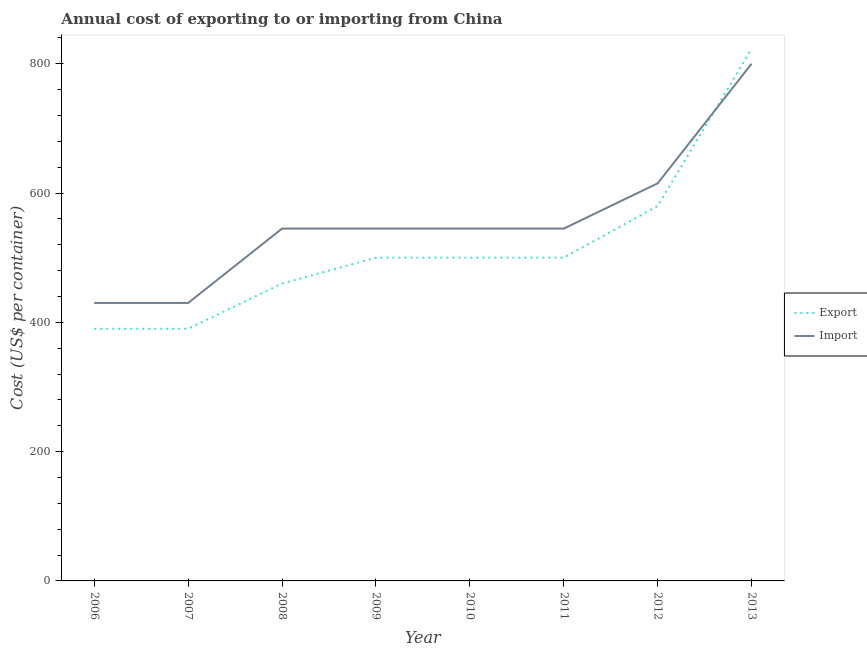Does the line corresponding to export cost intersect with the line corresponding to import cost?
Ensure brevity in your answer.  Yes. Is the number of lines equal to the number of legend labels?
Keep it short and to the point. Yes. What is the import cost in 2010?
Your response must be concise. 545. Across all years, what is the maximum export cost?
Your response must be concise. 823. Across all years, what is the minimum import cost?
Keep it short and to the point. 430. In which year was the import cost maximum?
Your answer should be very brief. 2013. What is the total import cost in the graph?
Offer a very short reply. 4455. What is the difference between the import cost in 2007 and that in 2013?
Your answer should be very brief. -370. What is the difference between the import cost in 2013 and the export cost in 2011?
Offer a very short reply. 300. What is the average import cost per year?
Offer a very short reply. 556.88. In the year 2006, what is the difference between the export cost and import cost?
Offer a terse response. -40. What is the ratio of the import cost in 2007 to that in 2009?
Your answer should be compact. 0.79. Is the difference between the import cost in 2006 and 2008 greater than the difference between the export cost in 2006 and 2008?
Your answer should be very brief. No. What is the difference between the highest and the second highest export cost?
Your answer should be compact. 243. What is the difference between the highest and the lowest export cost?
Provide a succinct answer. 433. Is the sum of the export cost in 2006 and 2010 greater than the maximum import cost across all years?
Your response must be concise. Yes. Is the export cost strictly greater than the import cost over the years?
Offer a terse response. No. How many lines are there?
Give a very brief answer. 2. How many years are there in the graph?
Keep it short and to the point. 8. Does the graph contain any zero values?
Provide a short and direct response. No. Does the graph contain grids?
Ensure brevity in your answer.  No. Where does the legend appear in the graph?
Offer a terse response. Center right. What is the title of the graph?
Keep it short and to the point. Annual cost of exporting to or importing from China. Does "All education staff compensation" appear as one of the legend labels in the graph?
Your response must be concise. No. What is the label or title of the Y-axis?
Make the answer very short. Cost (US$ per container). What is the Cost (US$ per container) in Export in 2006?
Provide a succinct answer. 390. What is the Cost (US$ per container) of Import in 2006?
Keep it short and to the point. 430. What is the Cost (US$ per container) of Export in 2007?
Your answer should be very brief. 390. What is the Cost (US$ per container) in Import in 2007?
Offer a terse response. 430. What is the Cost (US$ per container) in Export in 2008?
Your answer should be compact. 460. What is the Cost (US$ per container) in Import in 2008?
Provide a succinct answer. 545. What is the Cost (US$ per container) of Import in 2009?
Provide a short and direct response. 545. What is the Cost (US$ per container) of Export in 2010?
Give a very brief answer. 500. What is the Cost (US$ per container) in Import in 2010?
Provide a succinct answer. 545. What is the Cost (US$ per container) in Export in 2011?
Keep it short and to the point. 500. What is the Cost (US$ per container) of Import in 2011?
Your answer should be very brief. 545. What is the Cost (US$ per container) in Export in 2012?
Ensure brevity in your answer.  580. What is the Cost (US$ per container) of Import in 2012?
Provide a short and direct response. 615. What is the Cost (US$ per container) in Export in 2013?
Provide a short and direct response. 823. What is the Cost (US$ per container) of Import in 2013?
Your answer should be very brief. 800. Across all years, what is the maximum Cost (US$ per container) of Export?
Make the answer very short. 823. Across all years, what is the maximum Cost (US$ per container) in Import?
Give a very brief answer. 800. Across all years, what is the minimum Cost (US$ per container) in Export?
Ensure brevity in your answer.  390. Across all years, what is the minimum Cost (US$ per container) of Import?
Your response must be concise. 430. What is the total Cost (US$ per container) in Export in the graph?
Your answer should be very brief. 4143. What is the total Cost (US$ per container) of Import in the graph?
Offer a very short reply. 4455. What is the difference between the Cost (US$ per container) of Export in 2006 and that in 2007?
Your response must be concise. 0. What is the difference between the Cost (US$ per container) of Export in 2006 and that in 2008?
Your answer should be compact. -70. What is the difference between the Cost (US$ per container) of Import in 2006 and that in 2008?
Give a very brief answer. -115. What is the difference between the Cost (US$ per container) of Export in 2006 and that in 2009?
Your response must be concise. -110. What is the difference between the Cost (US$ per container) in Import in 2006 and that in 2009?
Your answer should be very brief. -115. What is the difference between the Cost (US$ per container) of Export in 2006 and that in 2010?
Provide a short and direct response. -110. What is the difference between the Cost (US$ per container) of Import in 2006 and that in 2010?
Your answer should be very brief. -115. What is the difference between the Cost (US$ per container) of Export in 2006 and that in 2011?
Provide a succinct answer. -110. What is the difference between the Cost (US$ per container) of Import in 2006 and that in 2011?
Offer a very short reply. -115. What is the difference between the Cost (US$ per container) of Export in 2006 and that in 2012?
Offer a very short reply. -190. What is the difference between the Cost (US$ per container) in Import in 2006 and that in 2012?
Your response must be concise. -185. What is the difference between the Cost (US$ per container) of Export in 2006 and that in 2013?
Ensure brevity in your answer.  -433. What is the difference between the Cost (US$ per container) in Import in 2006 and that in 2013?
Provide a succinct answer. -370. What is the difference between the Cost (US$ per container) of Export in 2007 and that in 2008?
Offer a very short reply. -70. What is the difference between the Cost (US$ per container) of Import in 2007 and that in 2008?
Make the answer very short. -115. What is the difference between the Cost (US$ per container) in Export in 2007 and that in 2009?
Your response must be concise. -110. What is the difference between the Cost (US$ per container) of Import in 2007 and that in 2009?
Keep it short and to the point. -115. What is the difference between the Cost (US$ per container) in Export in 2007 and that in 2010?
Your answer should be compact. -110. What is the difference between the Cost (US$ per container) of Import in 2007 and that in 2010?
Keep it short and to the point. -115. What is the difference between the Cost (US$ per container) in Export in 2007 and that in 2011?
Your response must be concise. -110. What is the difference between the Cost (US$ per container) of Import in 2007 and that in 2011?
Your answer should be very brief. -115. What is the difference between the Cost (US$ per container) in Export in 2007 and that in 2012?
Give a very brief answer. -190. What is the difference between the Cost (US$ per container) in Import in 2007 and that in 2012?
Offer a terse response. -185. What is the difference between the Cost (US$ per container) in Export in 2007 and that in 2013?
Ensure brevity in your answer.  -433. What is the difference between the Cost (US$ per container) of Import in 2007 and that in 2013?
Provide a succinct answer. -370. What is the difference between the Cost (US$ per container) of Export in 2008 and that in 2010?
Offer a very short reply. -40. What is the difference between the Cost (US$ per container) in Import in 2008 and that in 2010?
Provide a succinct answer. 0. What is the difference between the Cost (US$ per container) in Import in 2008 and that in 2011?
Provide a succinct answer. 0. What is the difference between the Cost (US$ per container) of Export in 2008 and that in 2012?
Give a very brief answer. -120. What is the difference between the Cost (US$ per container) of Import in 2008 and that in 2012?
Provide a short and direct response. -70. What is the difference between the Cost (US$ per container) of Export in 2008 and that in 2013?
Your response must be concise. -363. What is the difference between the Cost (US$ per container) in Import in 2008 and that in 2013?
Make the answer very short. -255. What is the difference between the Cost (US$ per container) of Export in 2009 and that in 2010?
Ensure brevity in your answer.  0. What is the difference between the Cost (US$ per container) of Import in 2009 and that in 2010?
Offer a very short reply. 0. What is the difference between the Cost (US$ per container) in Import in 2009 and that in 2011?
Your answer should be very brief. 0. What is the difference between the Cost (US$ per container) of Export in 2009 and that in 2012?
Offer a very short reply. -80. What is the difference between the Cost (US$ per container) in Import in 2009 and that in 2012?
Make the answer very short. -70. What is the difference between the Cost (US$ per container) in Export in 2009 and that in 2013?
Provide a short and direct response. -323. What is the difference between the Cost (US$ per container) in Import in 2009 and that in 2013?
Your response must be concise. -255. What is the difference between the Cost (US$ per container) of Export in 2010 and that in 2012?
Your answer should be very brief. -80. What is the difference between the Cost (US$ per container) in Import in 2010 and that in 2012?
Your response must be concise. -70. What is the difference between the Cost (US$ per container) of Export in 2010 and that in 2013?
Your response must be concise. -323. What is the difference between the Cost (US$ per container) of Import in 2010 and that in 2013?
Offer a very short reply. -255. What is the difference between the Cost (US$ per container) in Export in 2011 and that in 2012?
Your answer should be compact. -80. What is the difference between the Cost (US$ per container) of Import in 2011 and that in 2012?
Give a very brief answer. -70. What is the difference between the Cost (US$ per container) in Export in 2011 and that in 2013?
Offer a very short reply. -323. What is the difference between the Cost (US$ per container) in Import in 2011 and that in 2013?
Offer a very short reply. -255. What is the difference between the Cost (US$ per container) of Export in 2012 and that in 2013?
Keep it short and to the point. -243. What is the difference between the Cost (US$ per container) of Import in 2012 and that in 2013?
Make the answer very short. -185. What is the difference between the Cost (US$ per container) of Export in 2006 and the Cost (US$ per container) of Import in 2008?
Offer a very short reply. -155. What is the difference between the Cost (US$ per container) in Export in 2006 and the Cost (US$ per container) in Import in 2009?
Make the answer very short. -155. What is the difference between the Cost (US$ per container) in Export in 2006 and the Cost (US$ per container) in Import in 2010?
Provide a short and direct response. -155. What is the difference between the Cost (US$ per container) of Export in 2006 and the Cost (US$ per container) of Import in 2011?
Your answer should be compact. -155. What is the difference between the Cost (US$ per container) of Export in 2006 and the Cost (US$ per container) of Import in 2012?
Keep it short and to the point. -225. What is the difference between the Cost (US$ per container) in Export in 2006 and the Cost (US$ per container) in Import in 2013?
Provide a succinct answer. -410. What is the difference between the Cost (US$ per container) of Export in 2007 and the Cost (US$ per container) of Import in 2008?
Keep it short and to the point. -155. What is the difference between the Cost (US$ per container) of Export in 2007 and the Cost (US$ per container) of Import in 2009?
Your response must be concise. -155. What is the difference between the Cost (US$ per container) of Export in 2007 and the Cost (US$ per container) of Import in 2010?
Provide a short and direct response. -155. What is the difference between the Cost (US$ per container) in Export in 2007 and the Cost (US$ per container) in Import in 2011?
Provide a succinct answer. -155. What is the difference between the Cost (US$ per container) in Export in 2007 and the Cost (US$ per container) in Import in 2012?
Your response must be concise. -225. What is the difference between the Cost (US$ per container) of Export in 2007 and the Cost (US$ per container) of Import in 2013?
Ensure brevity in your answer.  -410. What is the difference between the Cost (US$ per container) in Export in 2008 and the Cost (US$ per container) in Import in 2009?
Give a very brief answer. -85. What is the difference between the Cost (US$ per container) in Export in 2008 and the Cost (US$ per container) in Import in 2010?
Give a very brief answer. -85. What is the difference between the Cost (US$ per container) of Export in 2008 and the Cost (US$ per container) of Import in 2011?
Offer a terse response. -85. What is the difference between the Cost (US$ per container) in Export in 2008 and the Cost (US$ per container) in Import in 2012?
Your answer should be compact. -155. What is the difference between the Cost (US$ per container) of Export in 2008 and the Cost (US$ per container) of Import in 2013?
Make the answer very short. -340. What is the difference between the Cost (US$ per container) in Export in 2009 and the Cost (US$ per container) in Import in 2010?
Ensure brevity in your answer.  -45. What is the difference between the Cost (US$ per container) of Export in 2009 and the Cost (US$ per container) of Import in 2011?
Offer a terse response. -45. What is the difference between the Cost (US$ per container) of Export in 2009 and the Cost (US$ per container) of Import in 2012?
Your answer should be very brief. -115. What is the difference between the Cost (US$ per container) in Export in 2009 and the Cost (US$ per container) in Import in 2013?
Make the answer very short. -300. What is the difference between the Cost (US$ per container) in Export in 2010 and the Cost (US$ per container) in Import in 2011?
Offer a very short reply. -45. What is the difference between the Cost (US$ per container) in Export in 2010 and the Cost (US$ per container) in Import in 2012?
Provide a short and direct response. -115. What is the difference between the Cost (US$ per container) of Export in 2010 and the Cost (US$ per container) of Import in 2013?
Your answer should be compact. -300. What is the difference between the Cost (US$ per container) of Export in 2011 and the Cost (US$ per container) of Import in 2012?
Your response must be concise. -115. What is the difference between the Cost (US$ per container) of Export in 2011 and the Cost (US$ per container) of Import in 2013?
Give a very brief answer. -300. What is the difference between the Cost (US$ per container) of Export in 2012 and the Cost (US$ per container) of Import in 2013?
Provide a succinct answer. -220. What is the average Cost (US$ per container) in Export per year?
Offer a very short reply. 517.88. What is the average Cost (US$ per container) in Import per year?
Provide a succinct answer. 556.88. In the year 2008, what is the difference between the Cost (US$ per container) in Export and Cost (US$ per container) in Import?
Offer a terse response. -85. In the year 2009, what is the difference between the Cost (US$ per container) in Export and Cost (US$ per container) in Import?
Offer a terse response. -45. In the year 2010, what is the difference between the Cost (US$ per container) of Export and Cost (US$ per container) of Import?
Your response must be concise. -45. In the year 2011, what is the difference between the Cost (US$ per container) in Export and Cost (US$ per container) in Import?
Provide a succinct answer. -45. In the year 2012, what is the difference between the Cost (US$ per container) of Export and Cost (US$ per container) of Import?
Your answer should be very brief. -35. What is the ratio of the Cost (US$ per container) of Import in 2006 to that in 2007?
Ensure brevity in your answer.  1. What is the ratio of the Cost (US$ per container) of Export in 2006 to that in 2008?
Offer a very short reply. 0.85. What is the ratio of the Cost (US$ per container) in Import in 2006 to that in 2008?
Provide a short and direct response. 0.79. What is the ratio of the Cost (US$ per container) in Export in 2006 to that in 2009?
Your answer should be compact. 0.78. What is the ratio of the Cost (US$ per container) in Import in 2006 to that in 2009?
Provide a succinct answer. 0.79. What is the ratio of the Cost (US$ per container) in Export in 2006 to that in 2010?
Your answer should be compact. 0.78. What is the ratio of the Cost (US$ per container) in Import in 2006 to that in 2010?
Make the answer very short. 0.79. What is the ratio of the Cost (US$ per container) of Export in 2006 to that in 2011?
Your response must be concise. 0.78. What is the ratio of the Cost (US$ per container) of Import in 2006 to that in 2011?
Provide a succinct answer. 0.79. What is the ratio of the Cost (US$ per container) in Export in 2006 to that in 2012?
Give a very brief answer. 0.67. What is the ratio of the Cost (US$ per container) in Import in 2006 to that in 2012?
Your answer should be compact. 0.7. What is the ratio of the Cost (US$ per container) of Export in 2006 to that in 2013?
Ensure brevity in your answer.  0.47. What is the ratio of the Cost (US$ per container) in Import in 2006 to that in 2013?
Provide a short and direct response. 0.54. What is the ratio of the Cost (US$ per container) in Export in 2007 to that in 2008?
Provide a succinct answer. 0.85. What is the ratio of the Cost (US$ per container) of Import in 2007 to that in 2008?
Give a very brief answer. 0.79. What is the ratio of the Cost (US$ per container) in Export in 2007 to that in 2009?
Ensure brevity in your answer.  0.78. What is the ratio of the Cost (US$ per container) in Import in 2007 to that in 2009?
Your answer should be compact. 0.79. What is the ratio of the Cost (US$ per container) of Export in 2007 to that in 2010?
Your response must be concise. 0.78. What is the ratio of the Cost (US$ per container) in Import in 2007 to that in 2010?
Provide a succinct answer. 0.79. What is the ratio of the Cost (US$ per container) in Export in 2007 to that in 2011?
Provide a succinct answer. 0.78. What is the ratio of the Cost (US$ per container) in Import in 2007 to that in 2011?
Offer a very short reply. 0.79. What is the ratio of the Cost (US$ per container) in Export in 2007 to that in 2012?
Keep it short and to the point. 0.67. What is the ratio of the Cost (US$ per container) of Import in 2007 to that in 2012?
Your answer should be compact. 0.7. What is the ratio of the Cost (US$ per container) of Export in 2007 to that in 2013?
Make the answer very short. 0.47. What is the ratio of the Cost (US$ per container) of Import in 2007 to that in 2013?
Keep it short and to the point. 0.54. What is the ratio of the Cost (US$ per container) of Export in 2008 to that in 2009?
Keep it short and to the point. 0.92. What is the ratio of the Cost (US$ per container) in Import in 2008 to that in 2009?
Your answer should be compact. 1. What is the ratio of the Cost (US$ per container) in Export in 2008 to that in 2010?
Offer a very short reply. 0.92. What is the ratio of the Cost (US$ per container) of Export in 2008 to that in 2012?
Your answer should be very brief. 0.79. What is the ratio of the Cost (US$ per container) of Import in 2008 to that in 2012?
Offer a very short reply. 0.89. What is the ratio of the Cost (US$ per container) of Export in 2008 to that in 2013?
Offer a terse response. 0.56. What is the ratio of the Cost (US$ per container) of Import in 2008 to that in 2013?
Provide a succinct answer. 0.68. What is the ratio of the Cost (US$ per container) of Export in 2009 to that in 2010?
Your answer should be compact. 1. What is the ratio of the Cost (US$ per container) of Export in 2009 to that in 2011?
Offer a terse response. 1. What is the ratio of the Cost (US$ per container) of Import in 2009 to that in 2011?
Offer a very short reply. 1. What is the ratio of the Cost (US$ per container) of Export in 2009 to that in 2012?
Offer a very short reply. 0.86. What is the ratio of the Cost (US$ per container) of Import in 2009 to that in 2012?
Keep it short and to the point. 0.89. What is the ratio of the Cost (US$ per container) of Export in 2009 to that in 2013?
Offer a terse response. 0.61. What is the ratio of the Cost (US$ per container) in Import in 2009 to that in 2013?
Provide a short and direct response. 0.68. What is the ratio of the Cost (US$ per container) in Export in 2010 to that in 2011?
Keep it short and to the point. 1. What is the ratio of the Cost (US$ per container) in Export in 2010 to that in 2012?
Provide a succinct answer. 0.86. What is the ratio of the Cost (US$ per container) of Import in 2010 to that in 2012?
Give a very brief answer. 0.89. What is the ratio of the Cost (US$ per container) in Export in 2010 to that in 2013?
Provide a short and direct response. 0.61. What is the ratio of the Cost (US$ per container) in Import in 2010 to that in 2013?
Make the answer very short. 0.68. What is the ratio of the Cost (US$ per container) in Export in 2011 to that in 2012?
Give a very brief answer. 0.86. What is the ratio of the Cost (US$ per container) in Import in 2011 to that in 2012?
Offer a terse response. 0.89. What is the ratio of the Cost (US$ per container) in Export in 2011 to that in 2013?
Offer a very short reply. 0.61. What is the ratio of the Cost (US$ per container) in Import in 2011 to that in 2013?
Keep it short and to the point. 0.68. What is the ratio of the Cost (US$ per container) in Export in 2012 to that in 2013?
Your response must be concise. 0.7. What is the ratio of the Cost (US$ per container) of Import in 2012 to that in 2013?
Offer a very short reply. 0.77. What is the difference between the highest and the second highest Cost (US$ per container) in Export?
Provide a succinct answer. 243. What is the difference between the highest and the second highest Cost (US$ per container) of Import?
Offer a terse response. 185. What is the difference between the highest and the lowest Cost (US$ per container) of Export?
Provide a succinct answer. 433. What is the difference between the highest and the lowest Cost (US$ per container) in Import?
Your answer should be very brief. 370. 